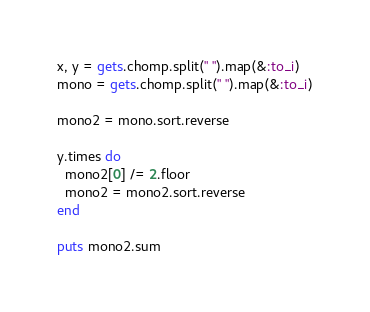<code> <loc_0><loc_0><loc_500><loc_500><_Ruby_>x, y = gets.chomp.split(" ").map(&:to_i)
mono = gets.chomp.split(" ").map(&:to_i)

mono2 = mono.sort.reverse

y.times do
  mono2[0] /= 2.floor
  mono2 = mono2.sort.reverse
end

puts mono2.sum
</code> 